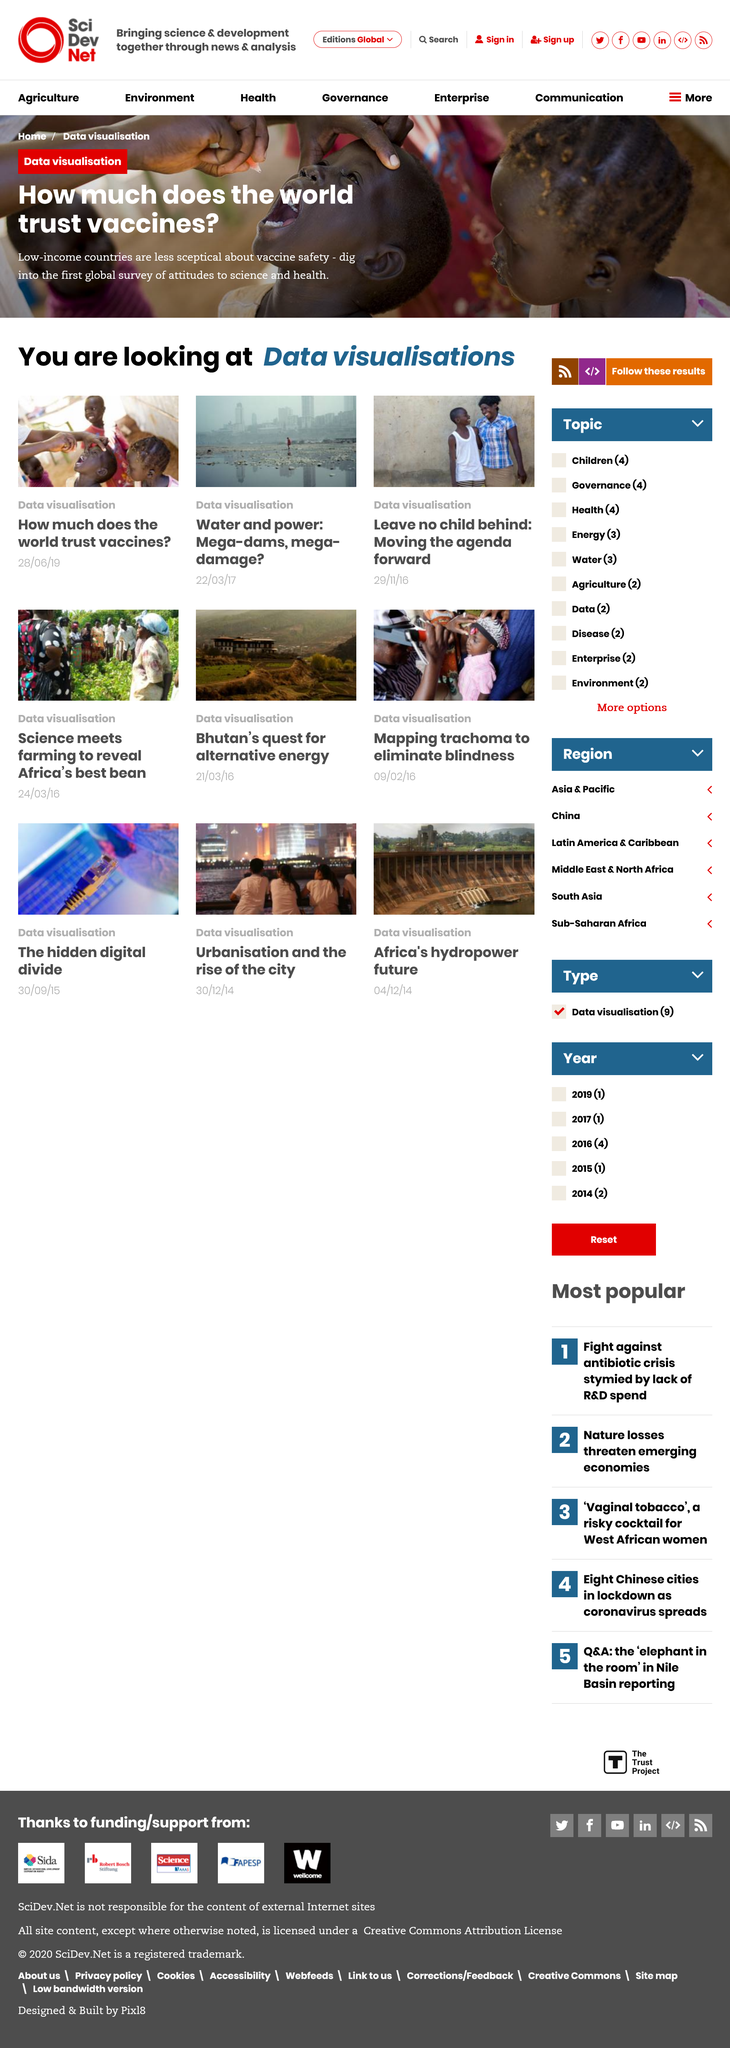Draw attention to some important aspects in this diagram. The article in the Data Visualization category about vaccines was published on June 28th, 2019. This article presents the findings of the first global survey on attitudes towards science and health, which explores the level of trust in vaccines globally. The article "Mega-dams, mega damage" discusses the topic of water and power generation in large dams. 